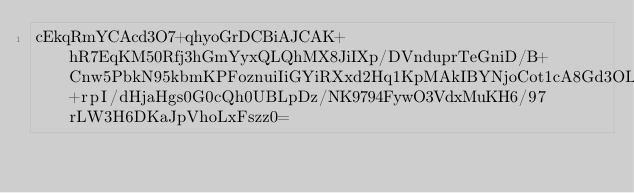Convert code to text. <code><loc_0><loc_0><loc_500><loc_500><_SML_>cEkqRmYCAcd3O7+qhyoGrDCBiAJCAK+hR7EqKM50Rfj3hGmYyxQLQhMX8JiIXp/DVnduprTeGniD/B+Cnw5PbkN95kbmKPFoznuiIiGYiRXxd2Hq1KpMAkIBYNjoCot1cA8Gd3OLoA+rpI/dHjaHgs0G0cQh0UBLpDz/NK9794FywO3VdxMuKH6/97rLW3H6DKaJpVhoLxFszz0=</code> 